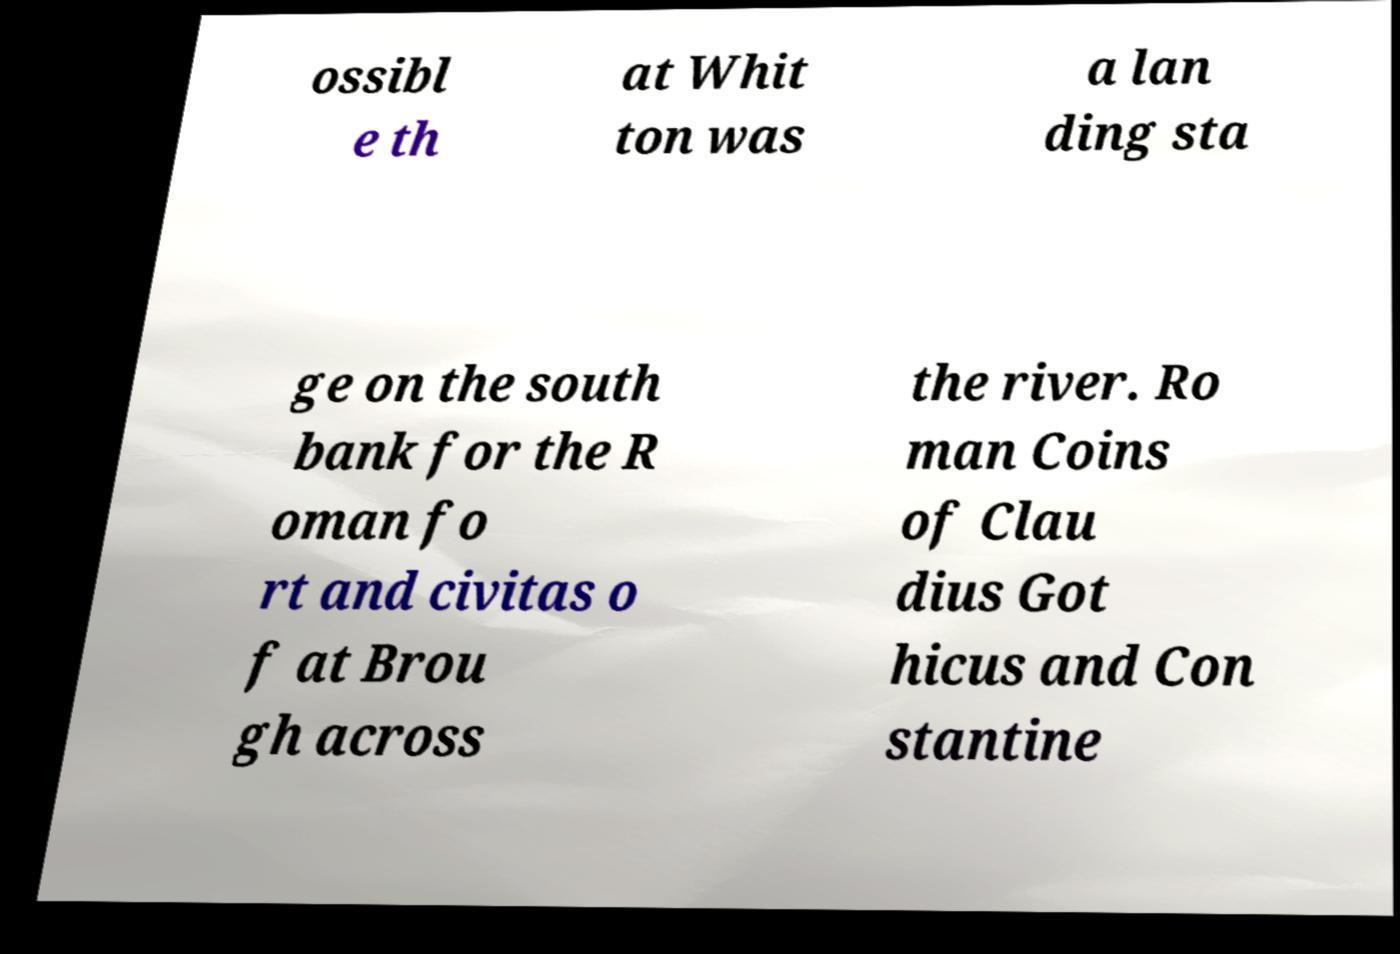For documentation purposes, I need the text within this image transcribed. Could you provide that? ossibl e th at Whit ton was a lan ding sta ge on the south bank for the R oman fo rt and civitas o f at Brou gh across the river. Ro man Coins of Clau dius Got hicus and Con stantine 